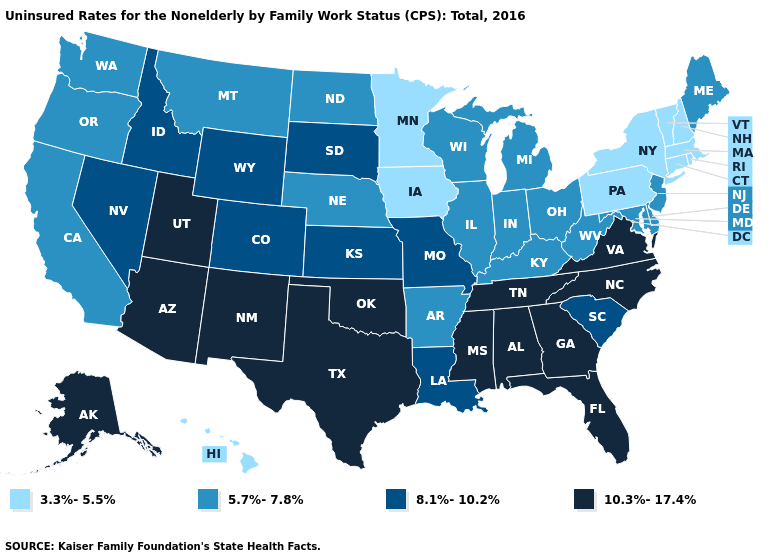Which states have the highest value in the USA?
Answer briefly. Alabama, Alaska, Arizona, Florida, Georgia, Mississippi, New Mexico, North Carolina, Oklahoma, Tennessee, Texas, Utah, Virginia. Name the states that have a value in the range 8.1%-10.2%?
Give a very brief answer. Colorado, Idaho, Kansas, Louisiana, Missouri, Nevada, South Carolina, South Dakota, Wyoming. What is the highest value in the Northeast ?
Keep it brief. 5.7%-7.8%. How many symbols are there in the legend?
Short answer required. 4. Does the first symbol in the legend represent the smallest category?
Answer briefly. Yes. What is the highest value in states that border Kentucky?
Write a very short answer. 10.3%-17.4%. What is the lowest value in states that border Louisiana?
Keep it brief. 5.7%-7.8%. What is the value of Washington?
Give a very brief answer. 5.7%-7.8%. Does the map have missing data?
Be succinct. No. What is the value of New Mexico?
Short answer required. 10.3%-17.4%. Does Vermont have the highest value in the Northeast?
Short answer required. No. What is the value of West Virginia?
Write a very short answer. 5.7%-7.8%. Among the states that border Delaware , which have the lowest value?
Give a very brief answer. Pennsylvania. What is the lowest value in states that border South Carolina?
Short answer required. 10.3%-17.4%. 